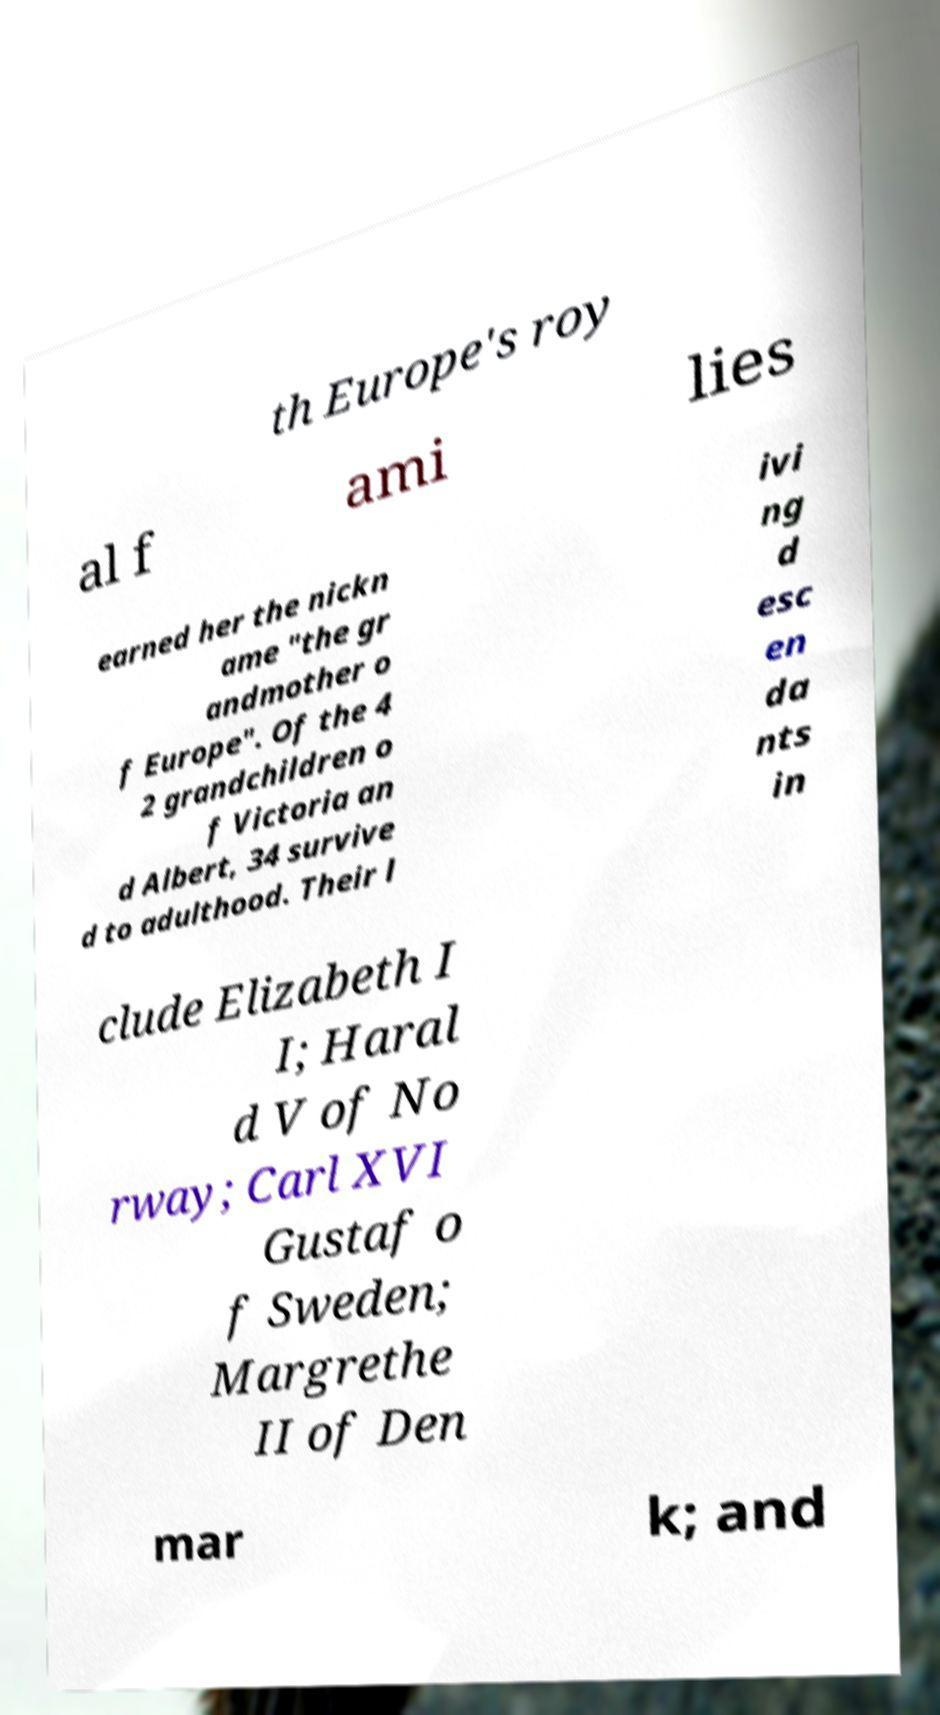Can you read and provide the text displayed in the image?This photo seems to have some interesting text. Can you extract and type it out for me? th Europe's roy al f ami lies earned her the nickn ame "the gr andmother o f Europe". Of the 4 2 grandchildren o f Victoria an d Albert, 34 survive d to adulthood. Their l ivi ng d esc en da nts in clude Elizabeth I I; Haral d V of No rway; Carl XVI Gustaf o f Sweden; Margrethe II of Den mar k; and 